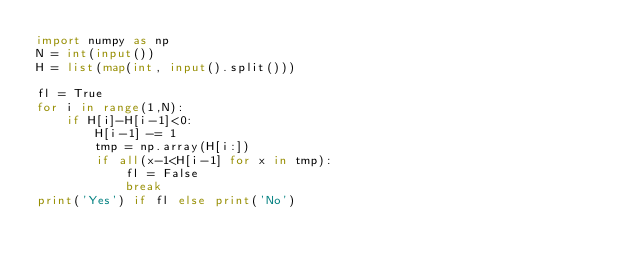<code> <loc_0><loc_0><loc_500><loc_500><_Python_>import numpy as np
N = int(input())
H = list(map(int, input().split()))

fl = True
for i in range(1,N):
    if H[i]-H[i-1]<0:
        H[i-1] -= 1
        tmp = np.array(H[i:])
        if all(x-1<H[i-1] for x in tmp):
            fl = False
            break
print('Yes') if fl else print('No')</code> 